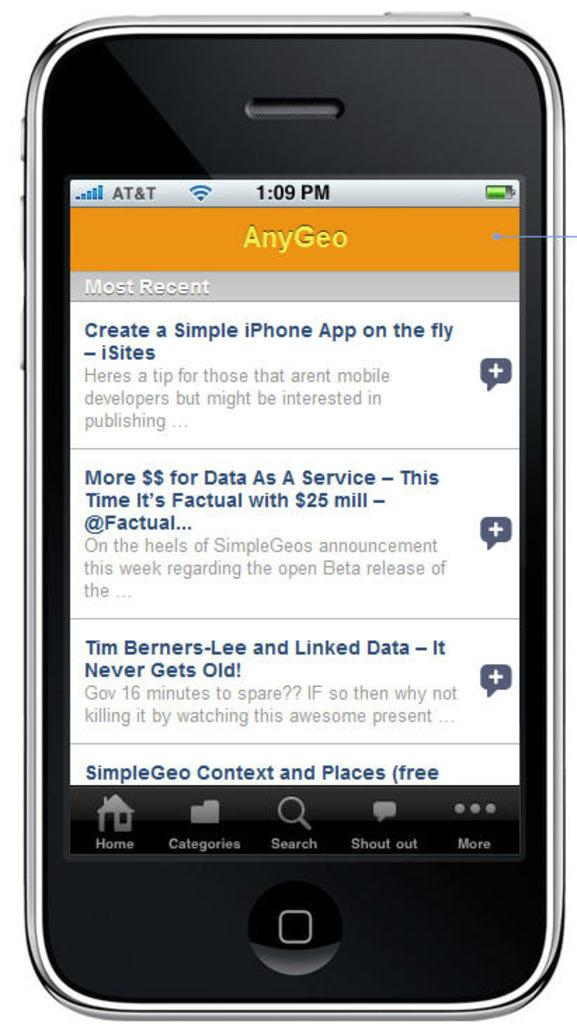<image>
Offer a succinct explanation of the picture presented. A cell phone showing an app on the screen called AnyGeo. 